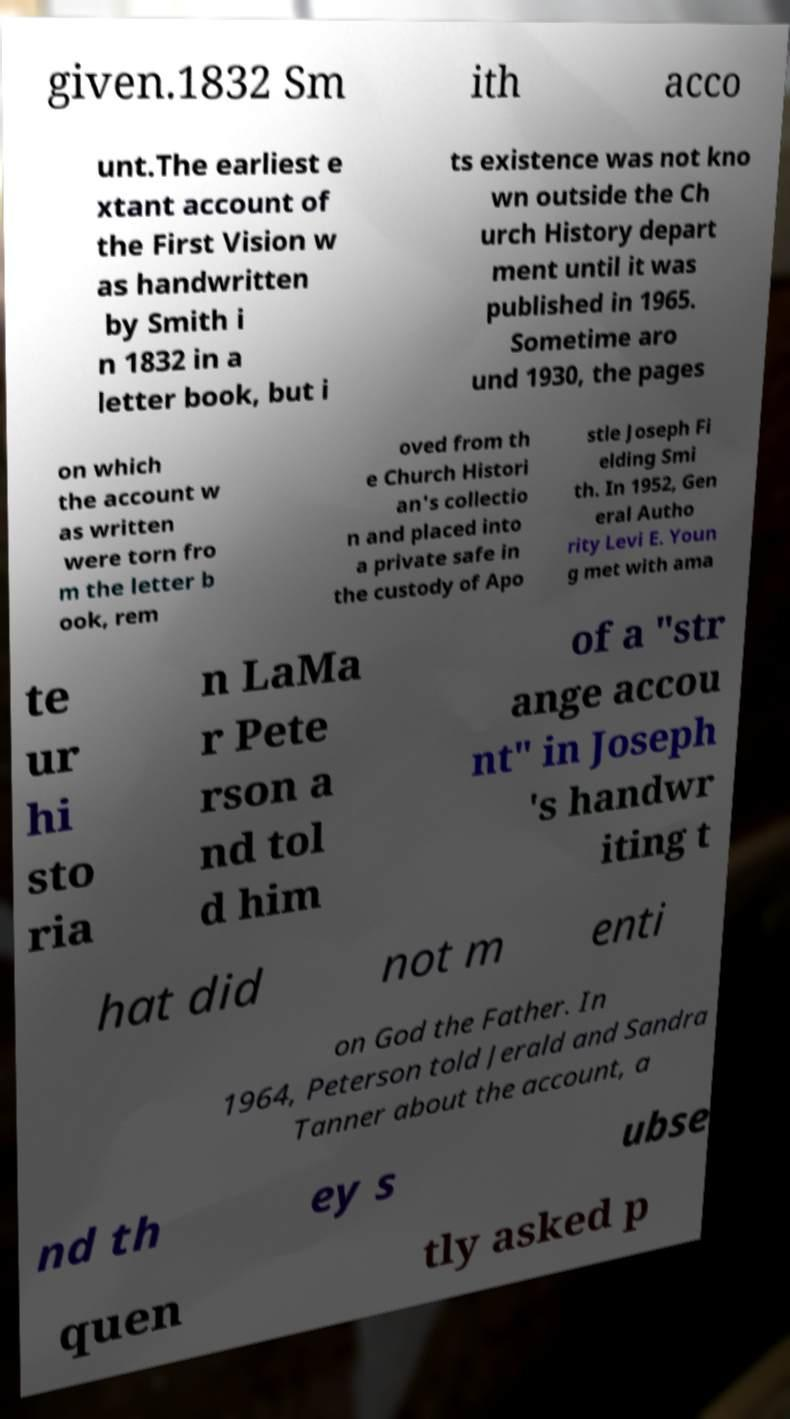Could you assist in decoding the text presented in this image and type it out clearly? given.1832 Sm ith acco unt.The earliest e xtant account of the First Vision w as handwritten by Smith i n 1832 in a letter book, but i ts existence was not kno wn outside the Ch urch History depart ment until it was published in 1965. Sometime aro und 1930, the pages on which the account w as written were torn fro m the letter b ook, rem oved from th e Church Histori an's collectio n and placed into a private safe in the custody of Apo stle Joseph Fi elding Smi th. In 1952, Gen eral Autho rity Levi E. Youn g met with ama te ur hi sto ria n LaMa r Pete rson a nd tol d him of a "str ange accou nt" in Joseph 's handwr iting t hat did not m enti on God the Father. In 1964, Peterson told Jerald and Sandra Tanner about the account, a nd th ey s ubse quen tly asked p 